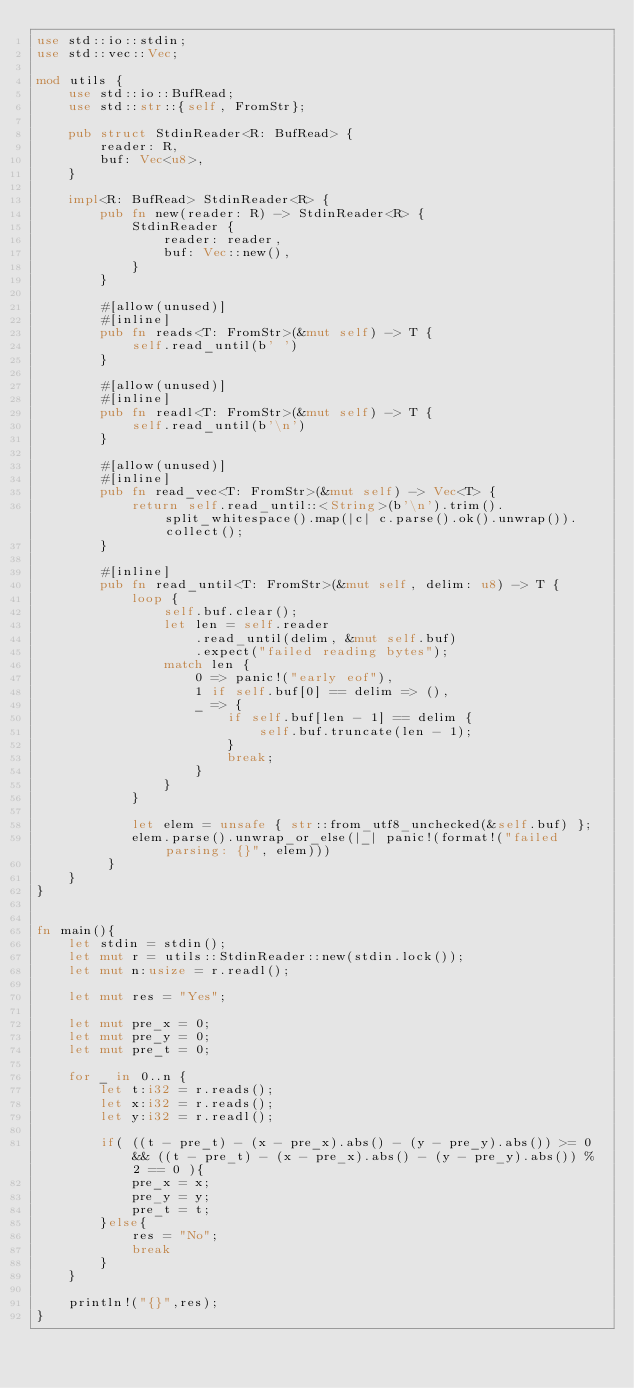<code> <loc_0><loc_0><loc_500><loc_500><_Rust_>use std::io::stdin;
use std::vec::Vec;

mod utils {
    use std::io::BufRead;
    use std::str::{self, FromStr};

    pub struct StdinReader<R: BufRead> {
        reader: R,
        buf: Vec<u8>,
    }

    impl<R: BufRead> StdinReader<R> {
        pub fn new(reader: R) -> StdinReader<R> {
            StdinReader {
                reader: reader,
                buf: Vec::new(),
            }
        }

        #[allow(unused)]
        #[inline]
        pub fn reads<T: FromStr>(&mut self) -> T {
            self.read_until(b' ')
        }

        #[allow(unused)]
        #[inline]
        pub fn readl<T: FromStr>(&mut self) -> T {
            self.read_until(b'\n')
        }

        #[allow(unused)]
        #[inline]
        pub fn read_vec<T: FromStr>(&mut self) -> Vec<T> {
            return self.read_until::<String>(b'\n').trim().split_whitespace().map(|c| c.parse().ok().unwrap()).collect();
        }

        #[inline]
        pub fn read_until<T: FromStr>(&mut self, delim: u8) -> T {
            loop {
                self.buf.clear();
                let len = self.reader
                    .read_until(delim, &mut self.buf)
                    .expect("failed reading bytes");
                match len {
                    0 => panic!("early eof"),
                    1 if self.buf[0] == delim => (),
                    _ => {
                        if self.buf[len - 1] == delim {
                            self.buf.truncate(len - 1);
                        }
                        break;
                    }
                }
            }

            let elem = unsafe { str::from_utf8_unchecked(&self.buf) };
            elem.parse().unwrap_or_else(|_| panic!(format!("failed parsing: {}", elem)))
         }
    }
}


fn main(){
    let stdin = stdin();
    let mut r = utils::StdinReader::new(stdin.lock());
    let mut n:usize = r.readl();

    let mut res = "Yes";

    let mut pre_x = 0;
    let mut pre_y = 0;
    let mut pre_t = 0;

    for _ in 0..n {
        let t:i32 = r.reads();
        let x:i32 = r.reads();
        let y:i32 = r.readl();

        if( ((t - pre_t) - (x - pre_x).abs() - (y - pre_y).abs()) >= 0 && ((t - pre_t) - (x - pre_x).abs() - (y - pre_y).abs()) % 2 == 0 ){
            pre_x = x;
            pre_y = y;
            pre_t = t;
        }else{
            res = "No";
            break
        }
    }

    println!("{}",res);
}
</code> 